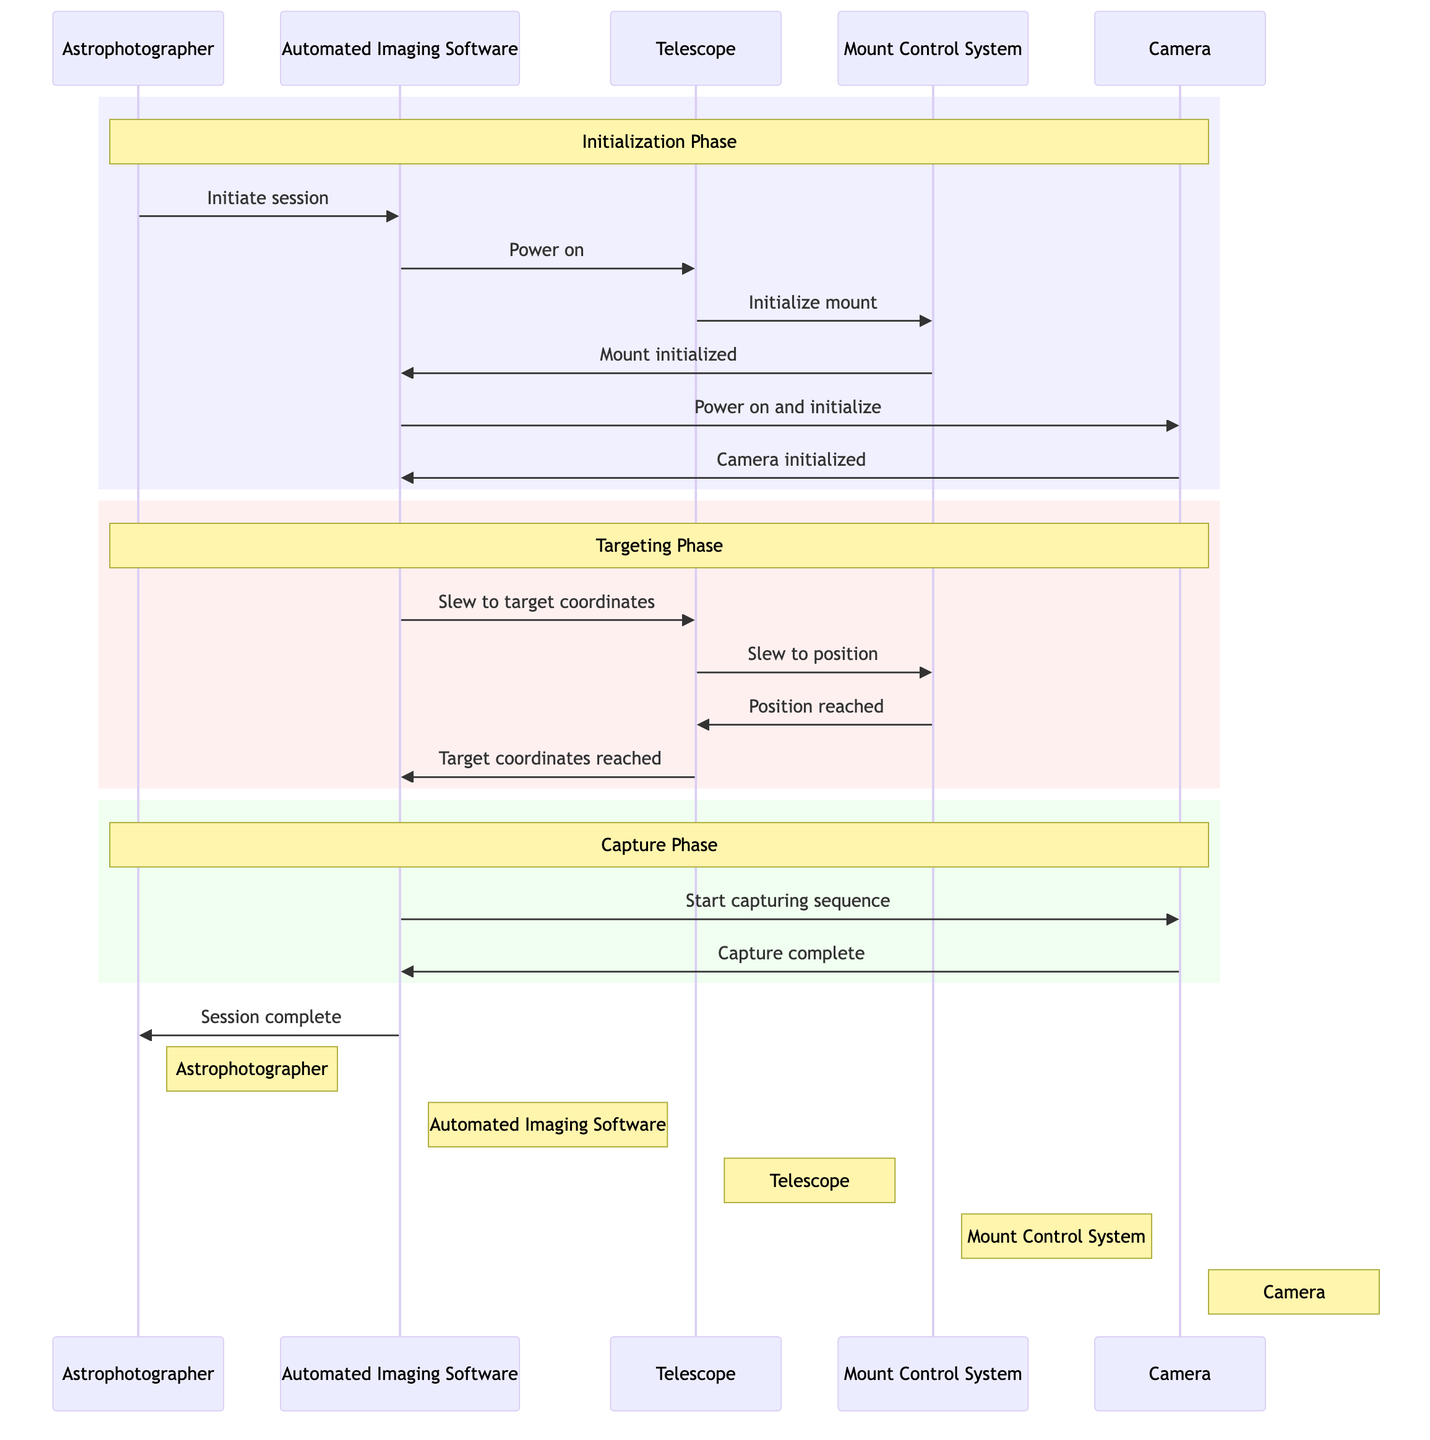What is the first message sent in the diagram? The first message sent in the diagram is from the Astrophotographer to the Automated Imaging Software, stating "Initiate session." This is identified by the initial arrow in the sequence diagram.
Answer: Initiate session How many actors are involved in the integration workflow? The integration workflow involves five actors: Astrophotographer, Telescope, Mount Control System, Camera, and Automated Imaging Software. This is determined by counting the distinct entities listed in the actors' section of the diagram.
Answer: Five What message is sent from the Mount Control System to the Automated Imaging Software after the mount is initialized? After the mount is initialized, the Mount Control System sends the message "Mount initialized" to the Automated Imaging Software. This message can be traced in the diagram's flow from the Mount Control System to the Automated Imaging Software.
Answer: Mount initialized What phase comes after the Initialization Phase? The phase that comes after the Initialization Phase is the Targeting Phase. This can be identified by observing the color-coded sections within the diagram, as they distinctly outline each phase.
Answer: Targeting Phase How many messages are exchanged during the Capture Phase? There are two messages exchanged during the Capture Phase: "Start capturing sequence" from the Automated Imaging Software to the Camera, and "Capture complete" from the Camera back to the Automated Imaging Software. This is counted by reviewing the messages listed within the specified phase section of the diagram.
Answer: Two Who is notified when the session is complete? The Astrophotographer is notified when the session is complete, as indicated by the message "Session complete" being sent from the Automated Imaging Software to the Astrophotographer. This conclusion is drawn from the final message interaction in the flow of the diagram.
Answer: Astrophotographer What is the last message sent in the sequence? The last message sent in the sequence is "Session complete" from the Automated Imaging Software to the Astrophotographer. This is identified as the final interaction at the end of the diagram's flow.
Answer: Session complete Which actor initiates the power on process for the Telescope? The actor that initiates the power on process for the Telescope is the Automated Imaging Software. This is evident as the first interaction where the Automated Imaging Software sends the "Power on" message to the Telescope.
Answer: Automated Imaging Software What message confirms the Telescope has reached the target coordinates? The message that confirms the Telescope has reached the target coordinates is "Target coordinates reached." This can be found in the series of interactions showing communication back to the Automated Imaging Software after the telescope has completed its slew.
Answer: Target coordinates reached 